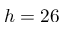Convert formula to latex. <formula><loc_0><loc_0><loc_500><loc_500>h = 2 6</formula> 